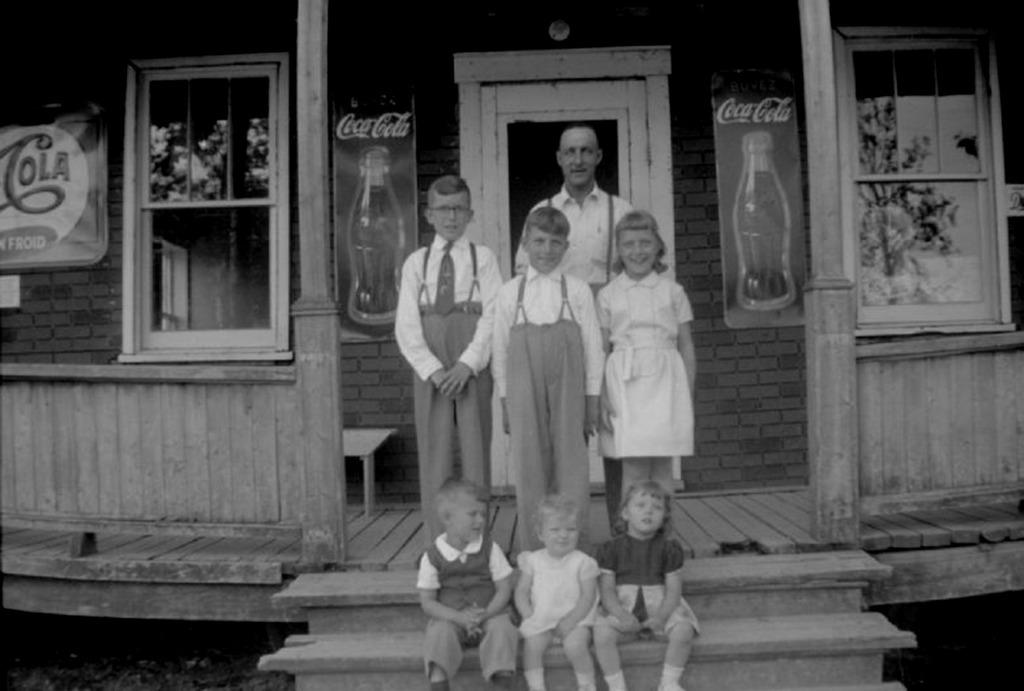What is the color scheme of the image? The image is black and white. What type of structure is visible in the image? There is a house in the image. What decorative items can be seen on the walls of the house? There are posters in the image. What feature allows light to enter the house? There are windows in the image. What are the people in the image doing? There are people standing and sitting in the image. What is the flavor of the land depicted in the image? There is no land depicted in the image, and therefore no flavor can be associated with it. What nation is represented by the people in the image? The image does not provide any information about the nationality of the people, so it cannot be determined which nation they represent. 